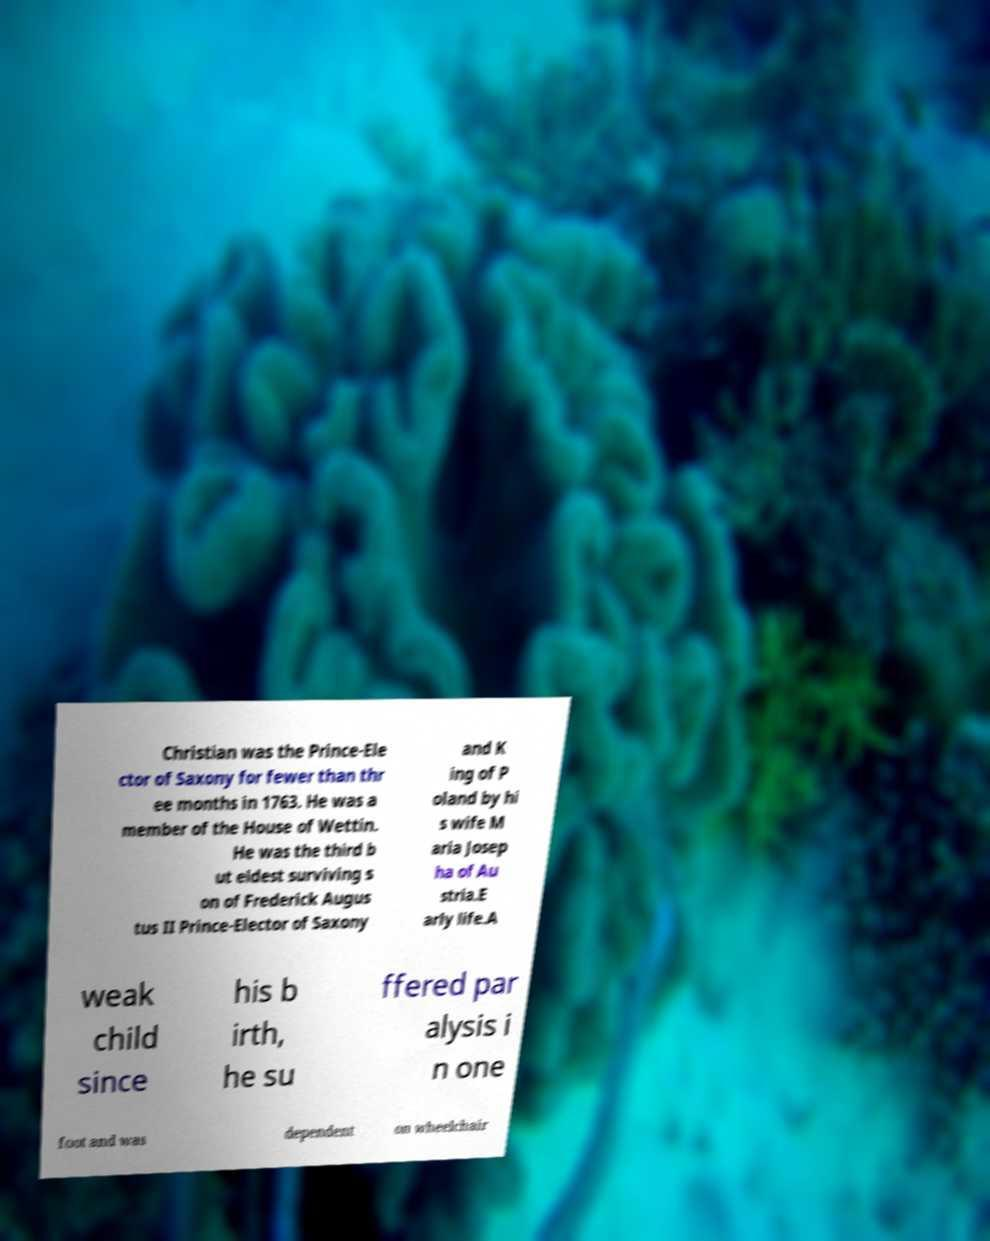Can you read and provide the text displayed in the image?This photo seems to have some interesting text. Can you extract and type it out for me? Christian was the Prince-Ele ctor of Saxony for fewer than thr ee months in 1763. He was a member of the House of Wettin. He was the third b ut eldest surviving s on of Frederick Augus tus II Prince-Elector of Saxony and K ing of P oland by hi s wife M aria Josep ha of Au stria.E arly life.A weak child since his b irth, he su ffered par alysis i n one foot and was dependent on wheelchair 